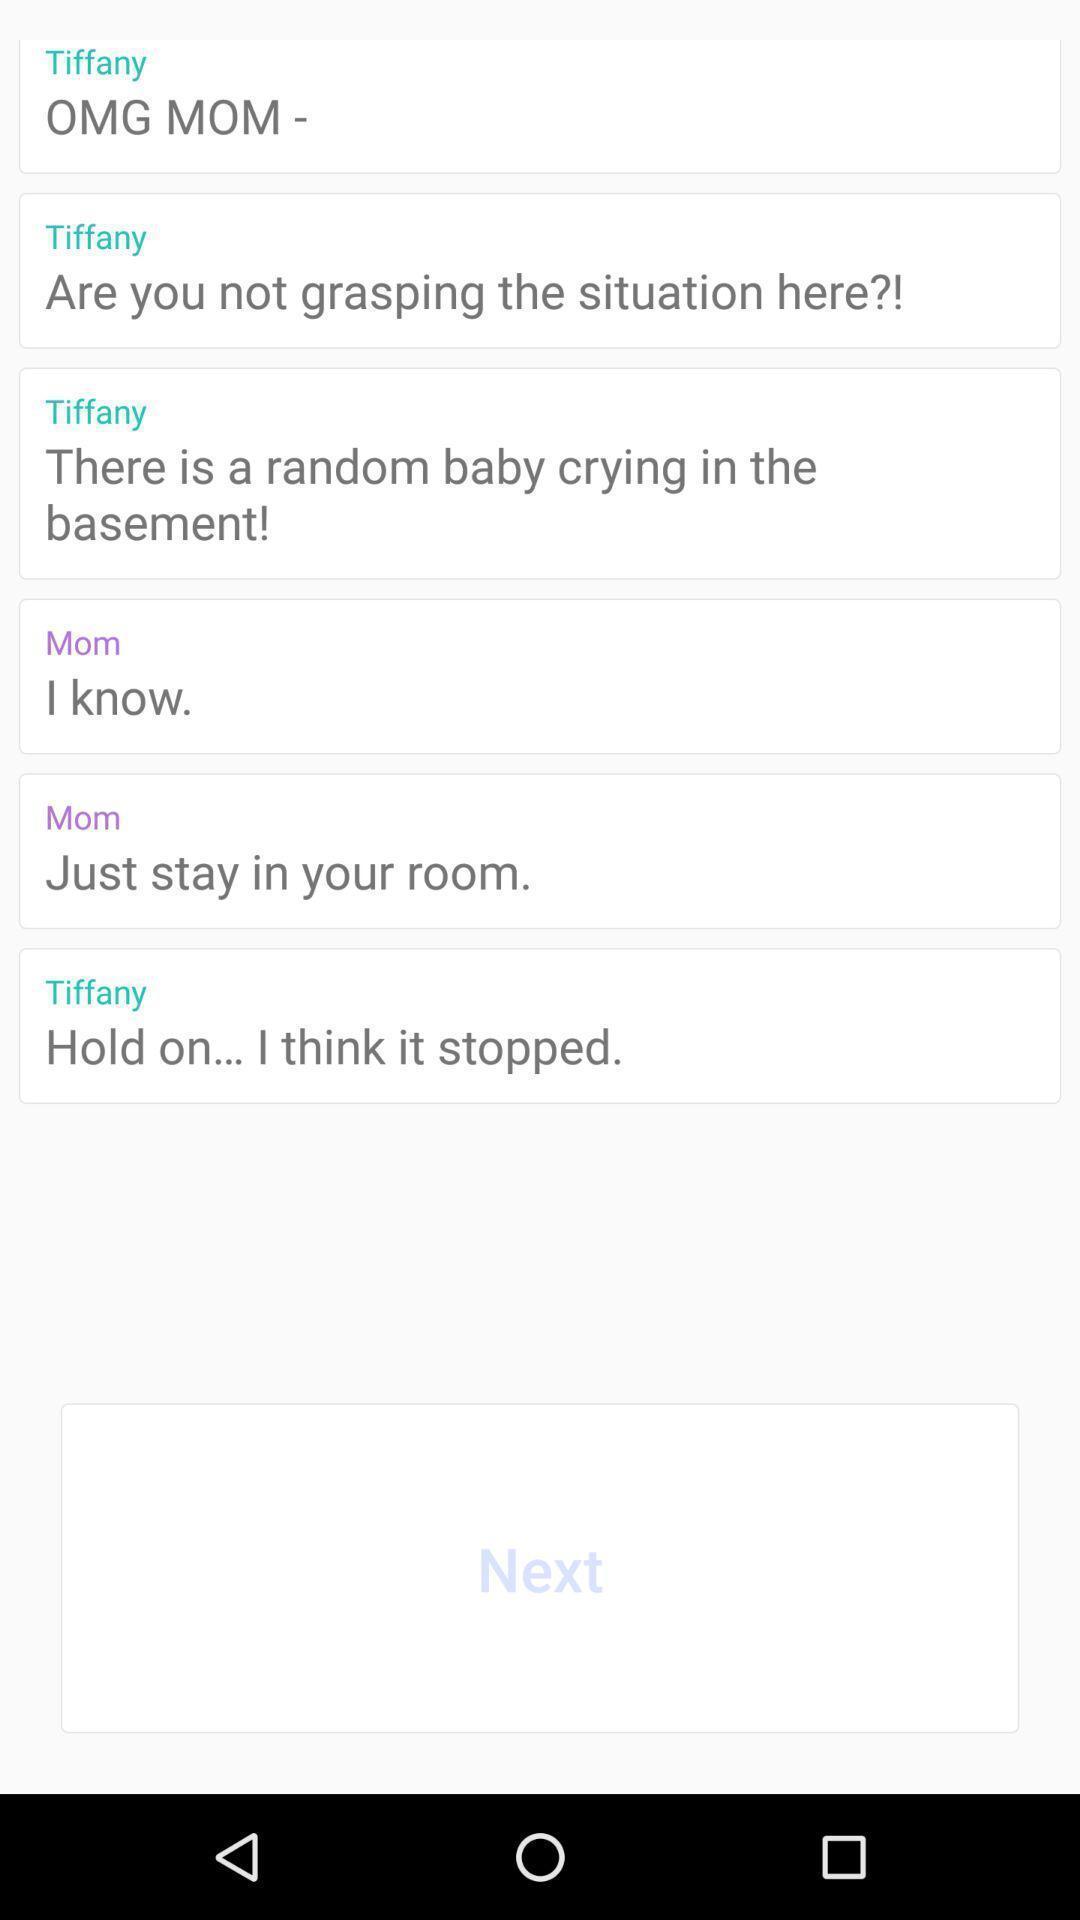Summarize the main components in this picture. Screen displaying the conversation on app. 